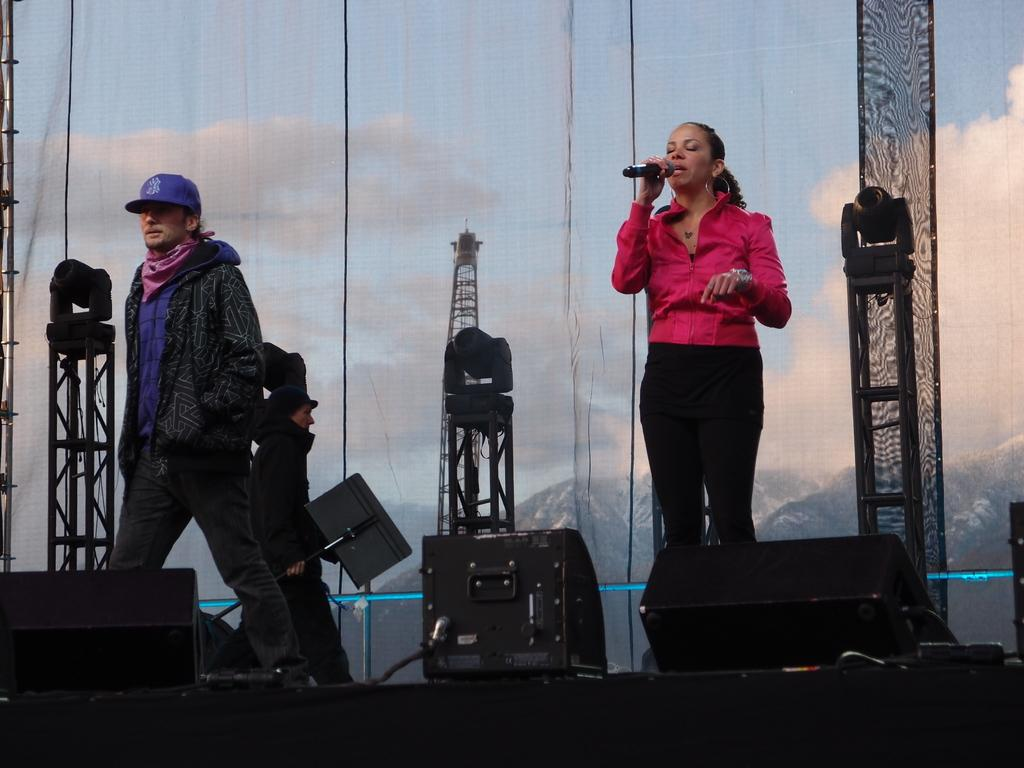How many people are in the image? There is a group of people in the image. What is the woman with the microphone doing? The woman is singing with the help of a microphone. What can be seen in the image that might be used for illumination? There are lights visible in the image. What equipment is present in the image that might be used for amplifying sound? There is a sound system in the image. What structures are visible in the image that might be used for holding equipment or instruments? There are stands in the image. What type of swing can be seen in the image? There is no swing present in the image. How many oranges are visible in the image? There are no oranges visible in the image. 